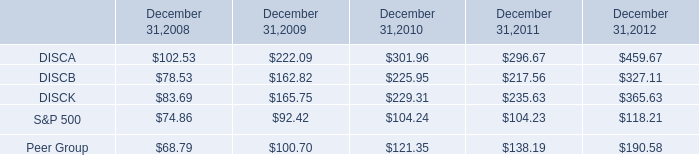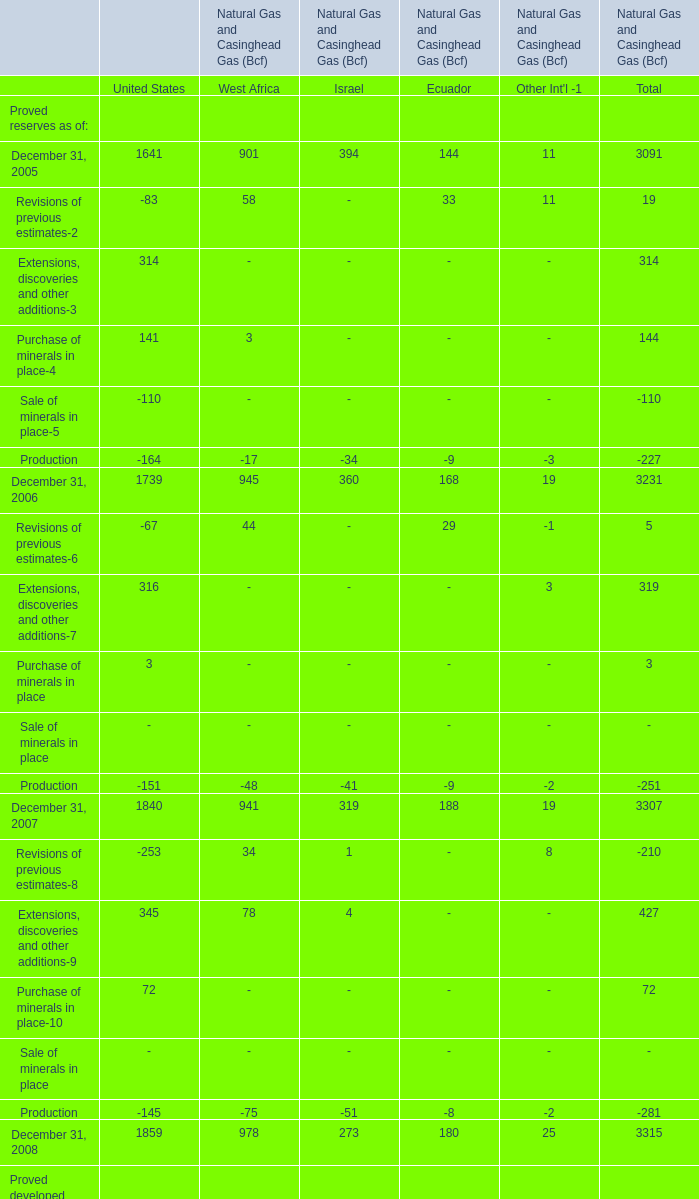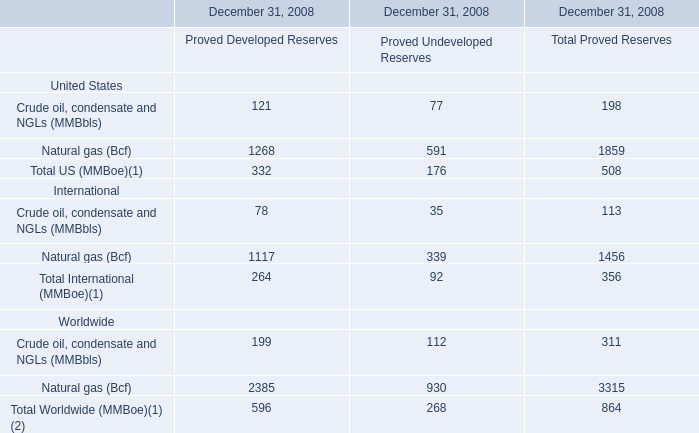How much of Revisions of previous estimates-2 is there in total (in 2005) without Israel and United states? 
Computations: ((58 + 33) + 11)
Answer: 102.0. 